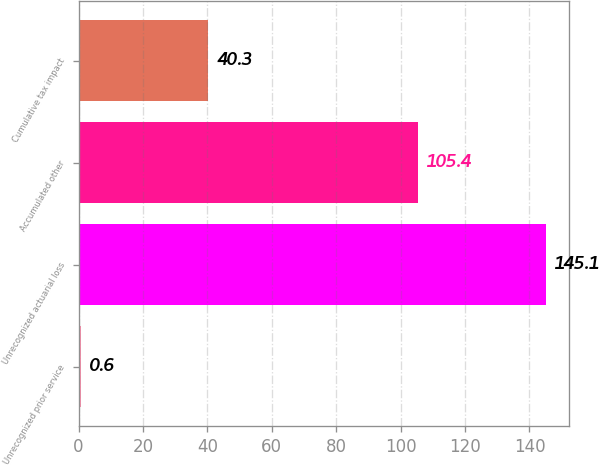Convert chart. <chart><loc_0><loc_0><loc_500><loc_500><bar_chart><fcel>Unrecognized prior service<fcel>Unrecognized actuarial loss<fcel>Accumulated other<fcel>Cumulative tax impact<nl><fcel>0.6<fcel>145.1<fcel>105.4<fcel>40.3<nl></chart> 